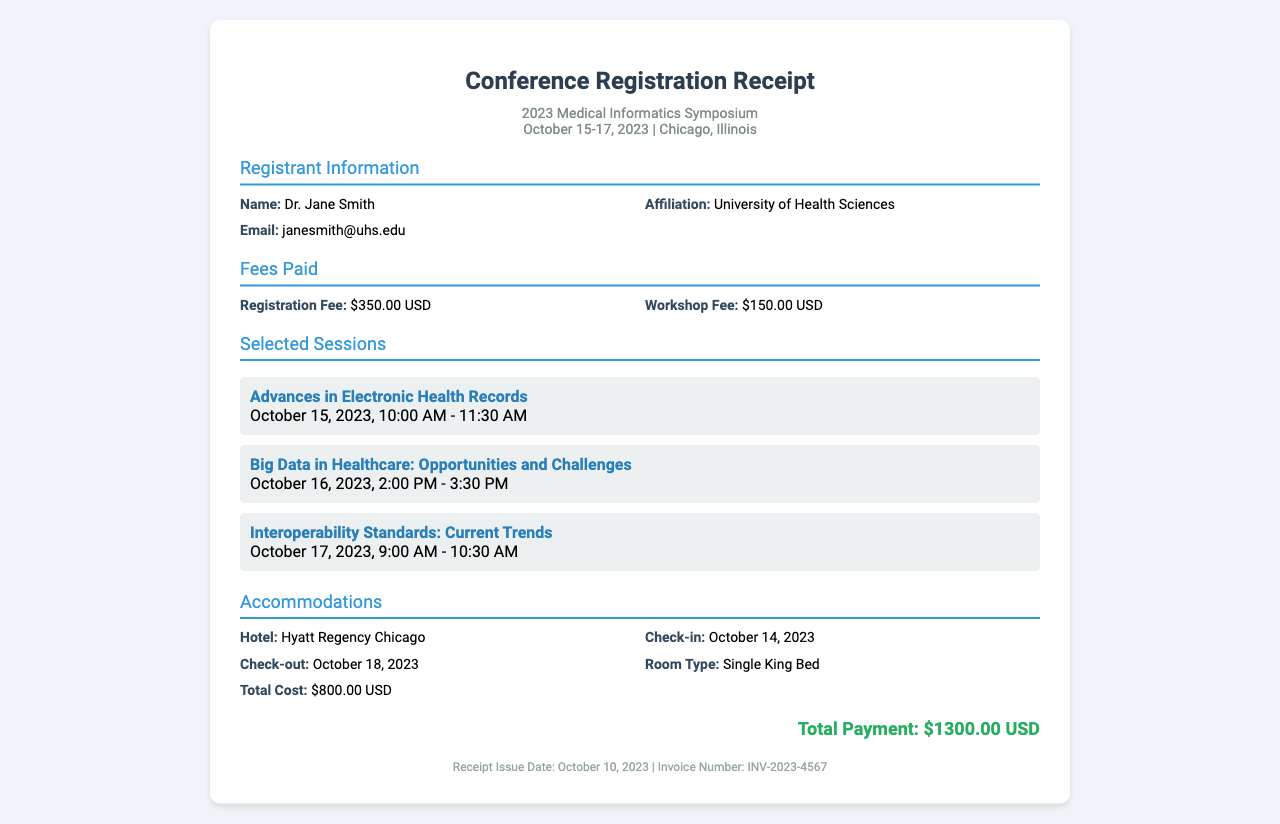What is the name of the registrant? The document states the registrant's name is Dr. Jane Smith.
Answer: Dr. Jane Smith What is the registration fee amount? The document lists the registration fee as $350.00 USD.
Answer: $350.00 USD What hotel is booked for accommodations? According to the document, the hotel booked is Hyatt Regency Chicago.
Answer: Hyatt Regency Chicago What is the total cost of accommodations? The total cost for the accommodations mentioned in the document is $800.00 USD.
Answer: $800.00 USD What date does the symposium take place? The document states that the symposium occurs from October 15-17, 2023.
Answer: October 15-17, 2023 How many sessions are selected by the registrant? The document lists three selected sessions in total.
Answer: 3 What is the total payment made? The document indicates the total payment made is $1300.00 USD.
Answer: $1300.00 USD When was the receipt issued? The document states the receipt was issued on October 10, 2023.
Answer: October 10, 2023 What is the invoice number? The document provides the invoice number as INV-2023-4567.
Answer: INV-2023-4567 